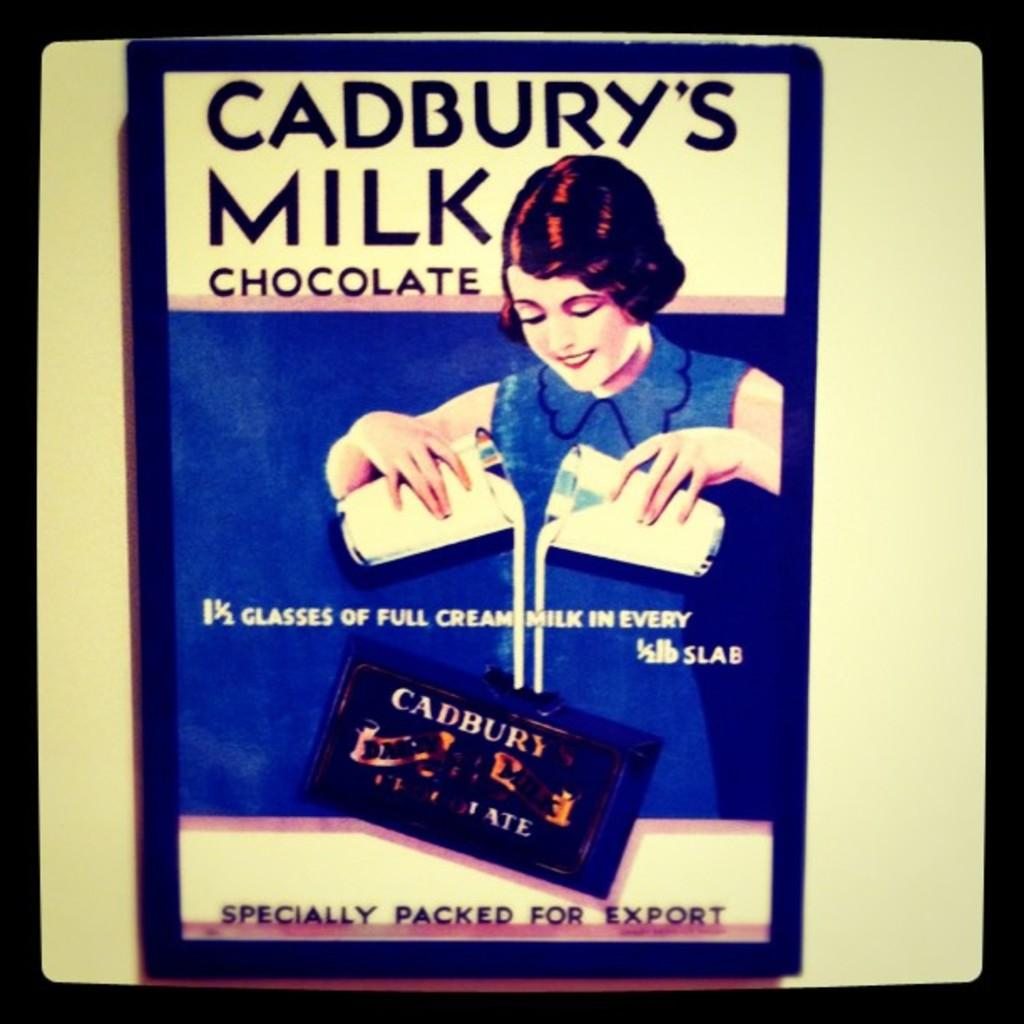<image>
Render a clear and concise summary of the photo. a picture of an advertisement for Cadbury's Milk 